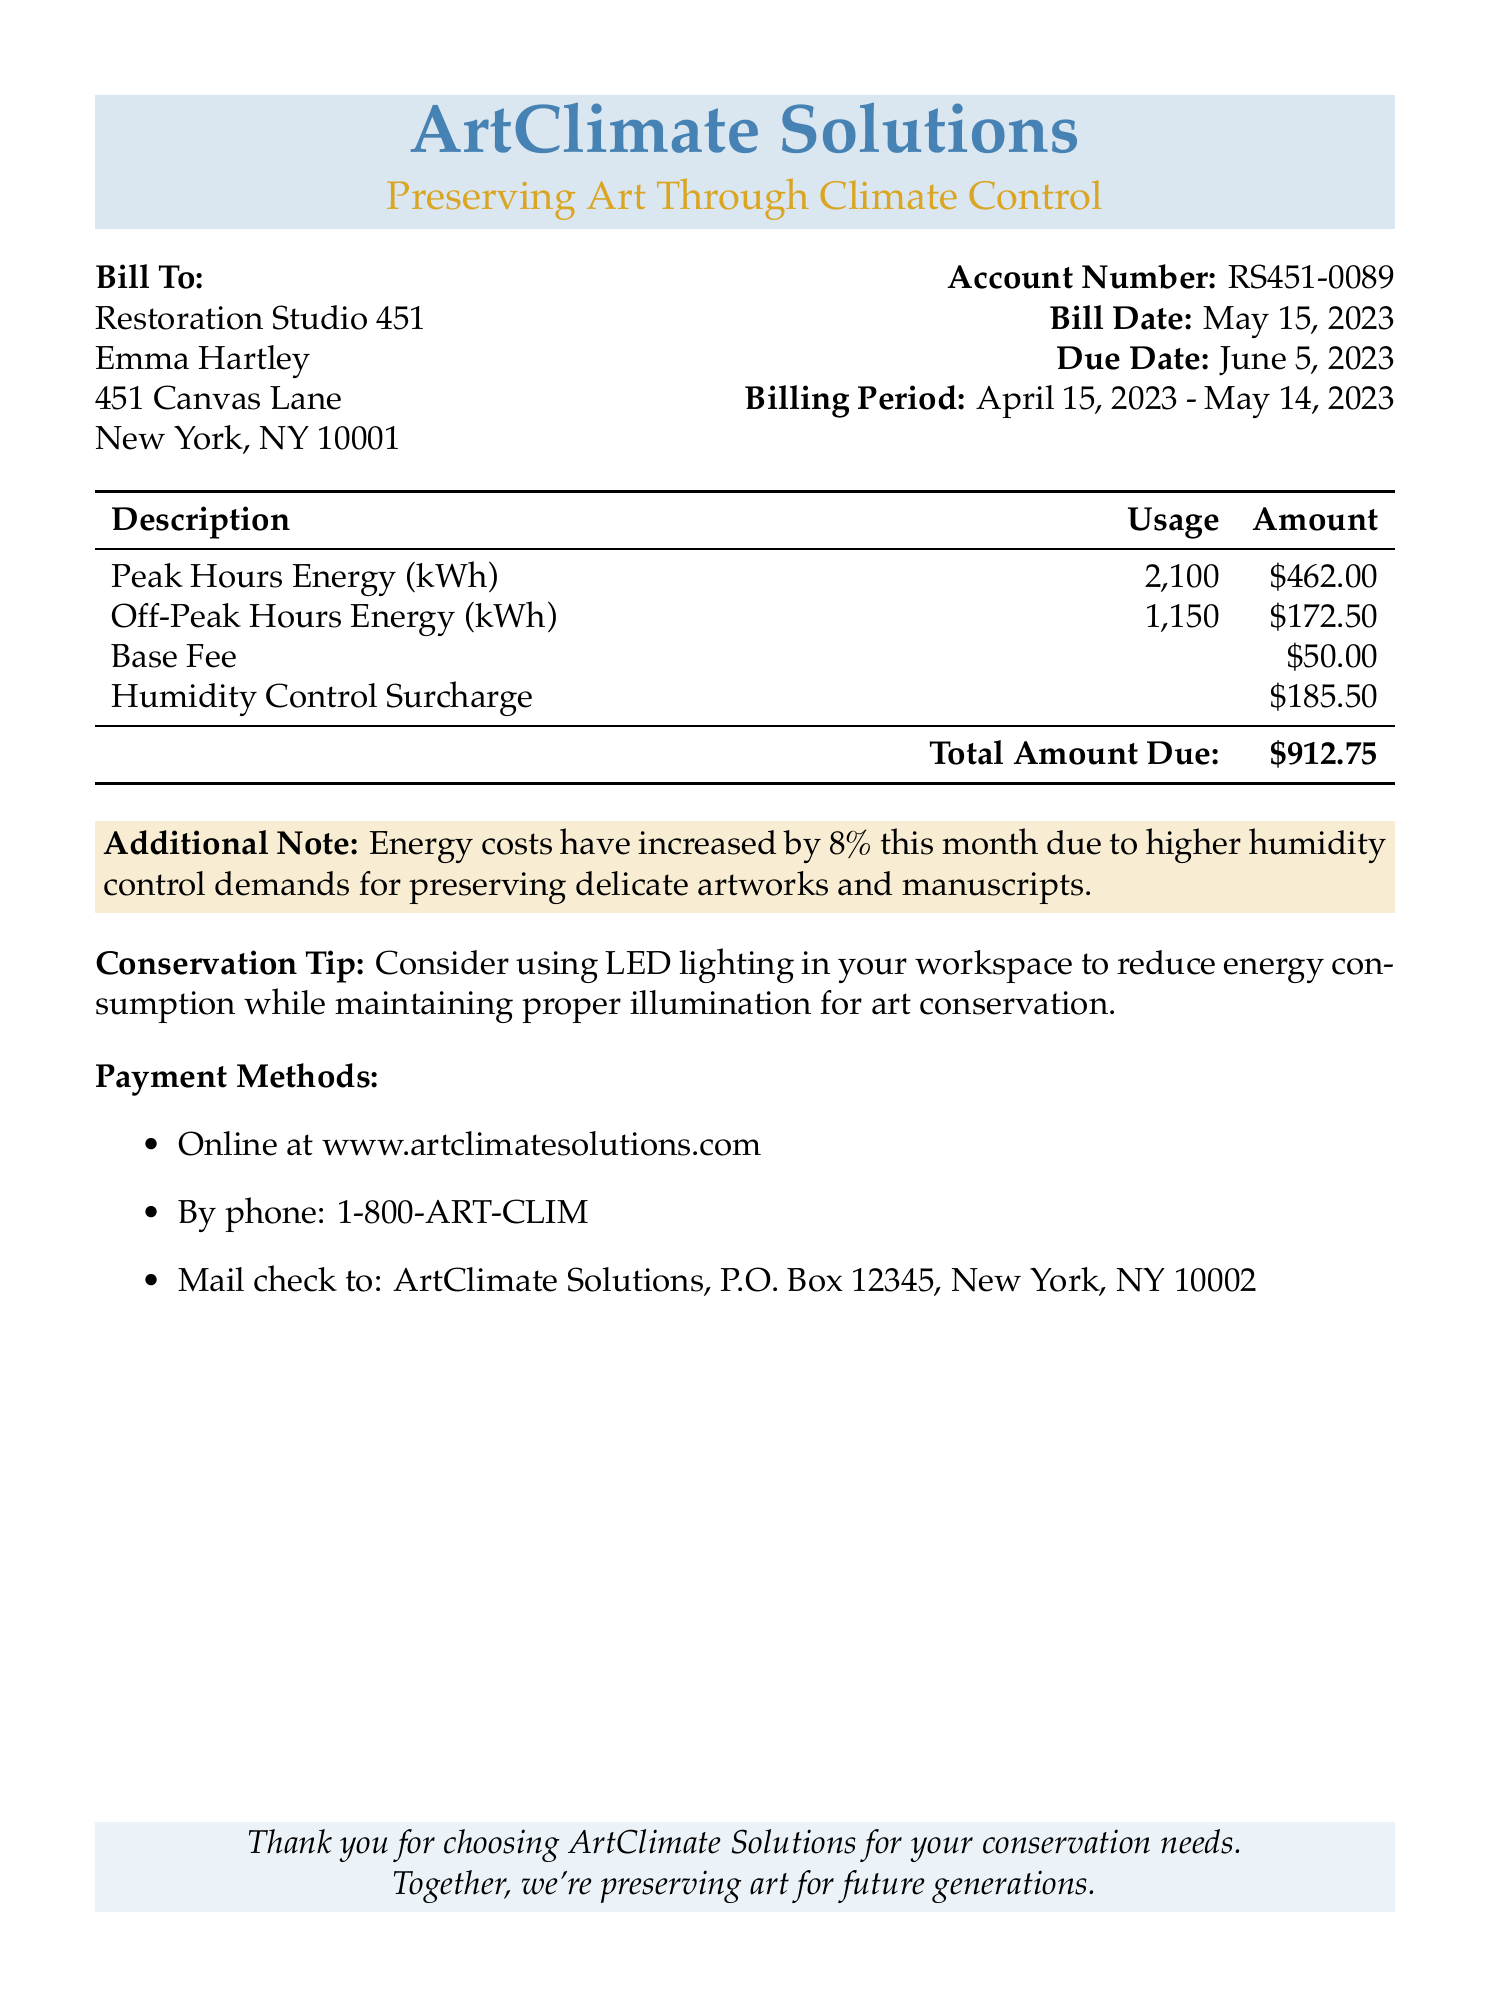What is the total amount due? The total amount due is listed as the sum of all the charges in the document.
Answer: $912.75 What is the billing period? The billing period specifies the dates during which the energy usage is calculated.
Answer: April 15, 2023 - May 14, 2023 Who is the bill addressed to? The document specifies the recipient's details under the "Bill To" section.
Answer: Restoration Studio 451 What is the humidity control surcharge amount? The document lists the surcharge specifically for humidity control as an additional fee.
Answer: $185.50 What percentage have energy costs increased this month? The document includes an additional note about the increase in energy costs, which is mentioned as a percentage.
Answer: 8% What is the base fee? The base fee is the fixed charge included in the total amount due.
Answer: $50.00 What is the usage for peak hours energy? The document details the energy consumed during peak hours.
Answer: 2,100 kWh What is the additional note regarding energy costs? The document contains a note explaining the reason behind the increased energy costs.
Answer: Energy costs have increased by 8% this month due to higher humidity control demands for preserving delicate artworks and manuscripts What are the payment methods? The document lists various payment options available for the recipient to settle the bill.
Answer: Online, by phone, or by mail 